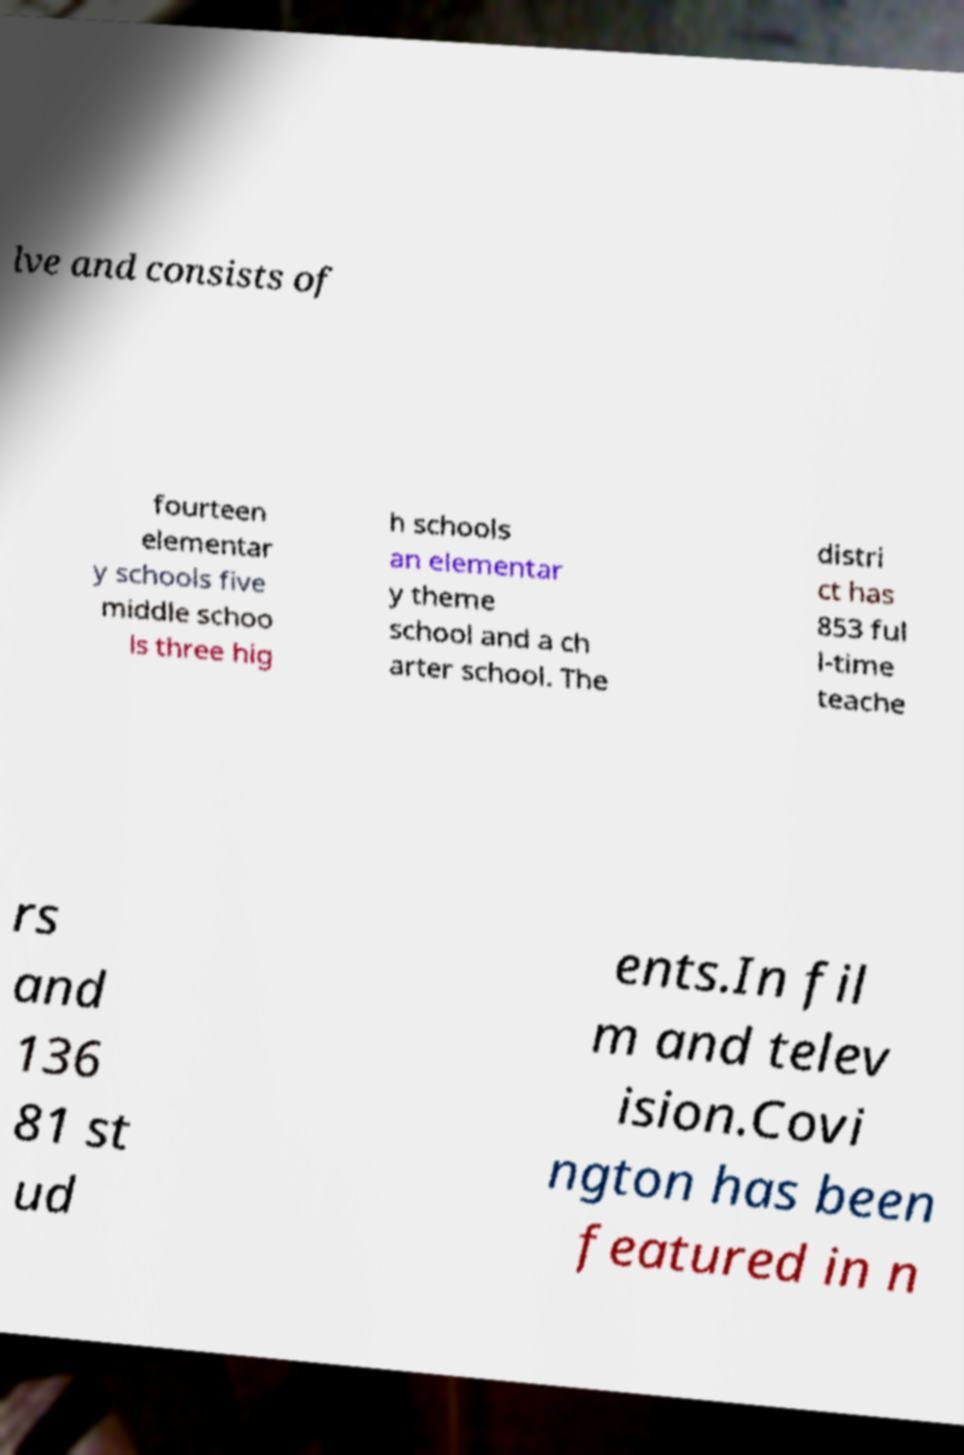Please read and relay the text visible in this image. What does it say? lve and consists of fourteen elementar y schools five middle schoo ls three hig h schools an elementar y theme school and a ch arter school. The distri ct has 853 ful l-time teache rs and 136 81 st ud ents.In fil m and telev ision.Covi ngton has been featured in n 